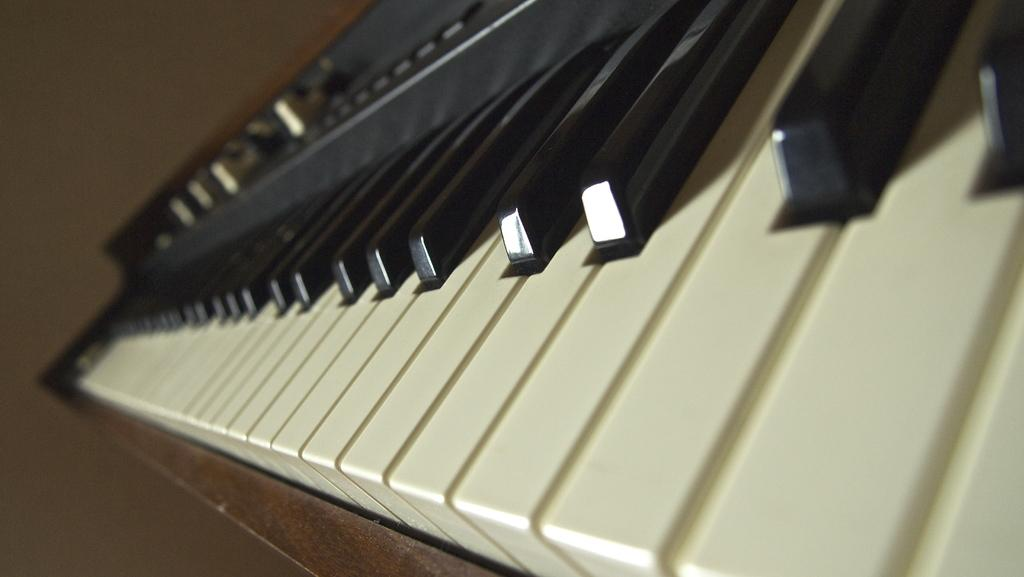What is the main object in the image? There is a piano in the image. What can be observed about the keys on the piano? The piano has white and black buttons (keys). What is located on the left side of the image? There is a wall on the left side of the image. How many steps are there leading up to the piano in the image? There are no steps visible in the image; the piano is directly on the floor. What type of railway is present in the image? There is no railway present in the image; it features a piano and a wall. 